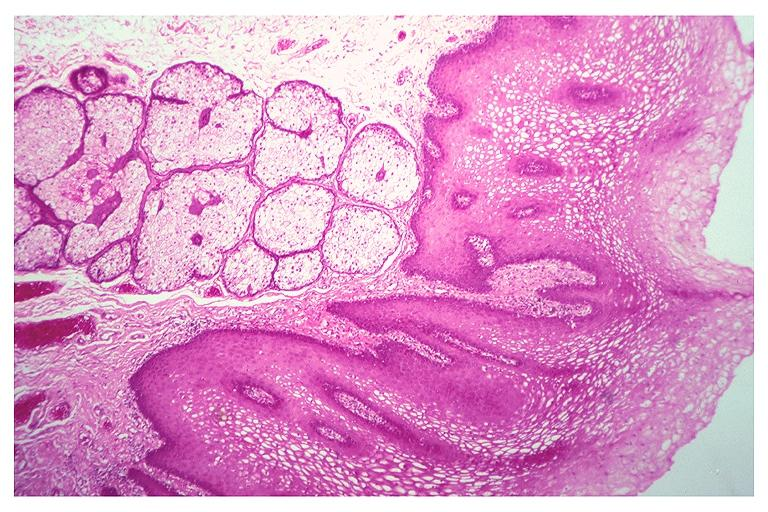where is this?
Answer the question using a single word or phrase. Oral 